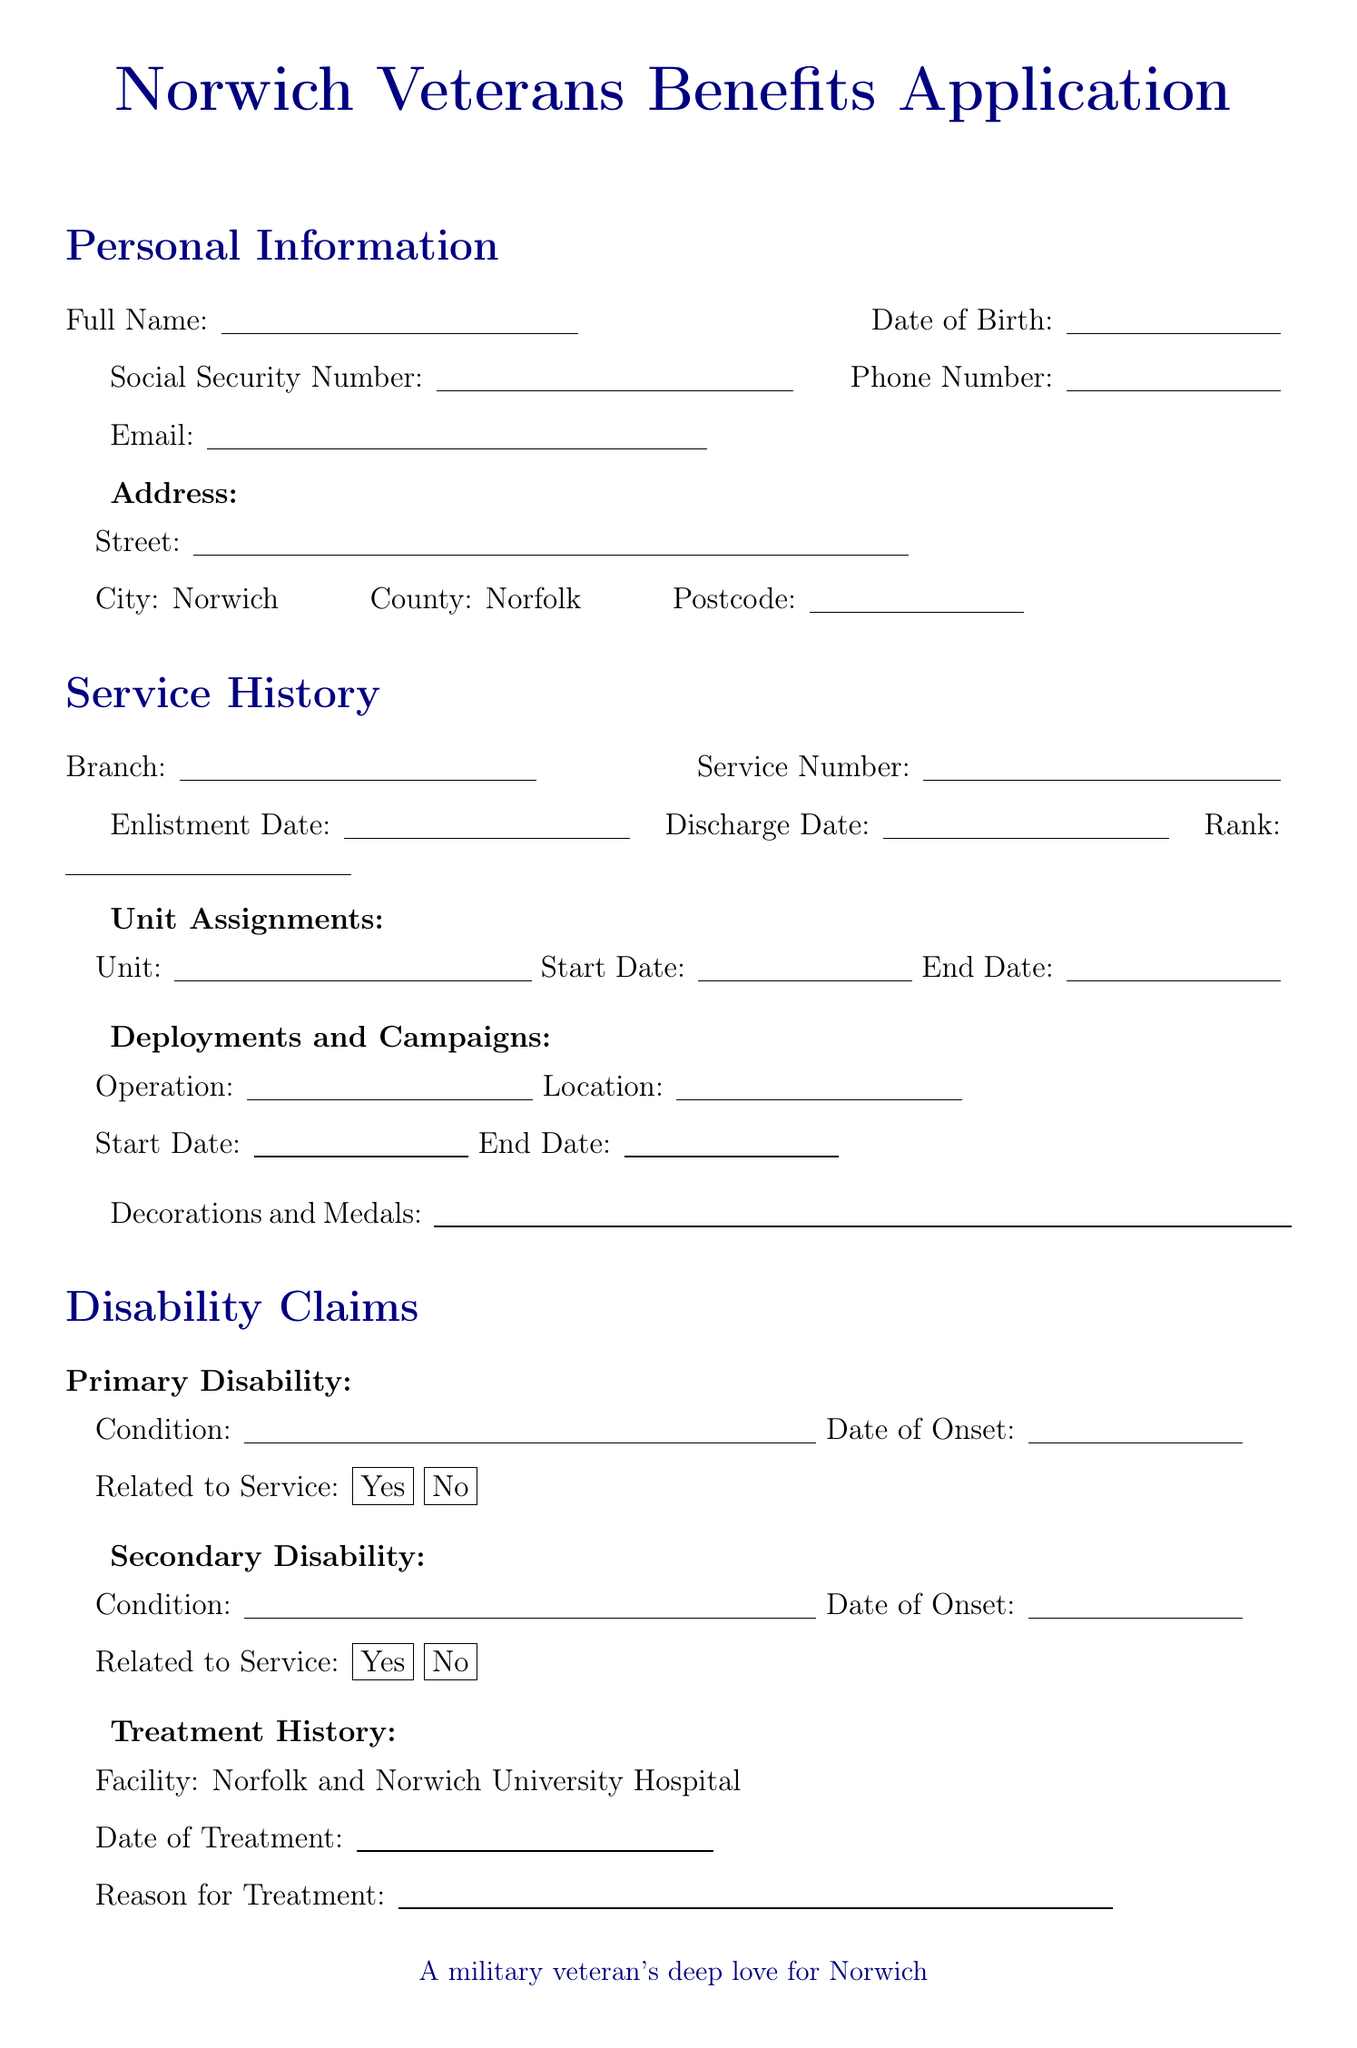What is the title of the form? The title of the form is indicated at the top of the document as the main heading.
Answer: Norwich Veterans Benefits Application What is the applicant’s city of residence? The city of residence is clearly listed in the address section of the document.
Answer: Norwich Which branch of service is listed in the options? The branches of service are provided as a list in the service history section of the document.
Answer: Royal Navy What is the facility for treatment history? The document specifies the treatment facility in the treatment history section.
Answer: Norfolk and Norwich University Hospital Is the applicant applying for education benefits? The document provides a checkbox option under additional benefits to indicate whether the applicant is applying for education benefits.
Answer: No What is the primary disability related to? The document asks if the primary disability is related to service in the disability claims section.
Answer: Yes How many veteran support groups are listed? The number of veteran support groups is shown in the local resources section of the document.
Answer: Two What is the preferred location for housing assistance? The preferred location for housing assistance is explicitly mentioned in the additional benefits section.
Answer: Norwich City Centre What is required for the privacy agreement? The privacy agreement section asks for consent to the processing of personal data.
Answer: Yes 